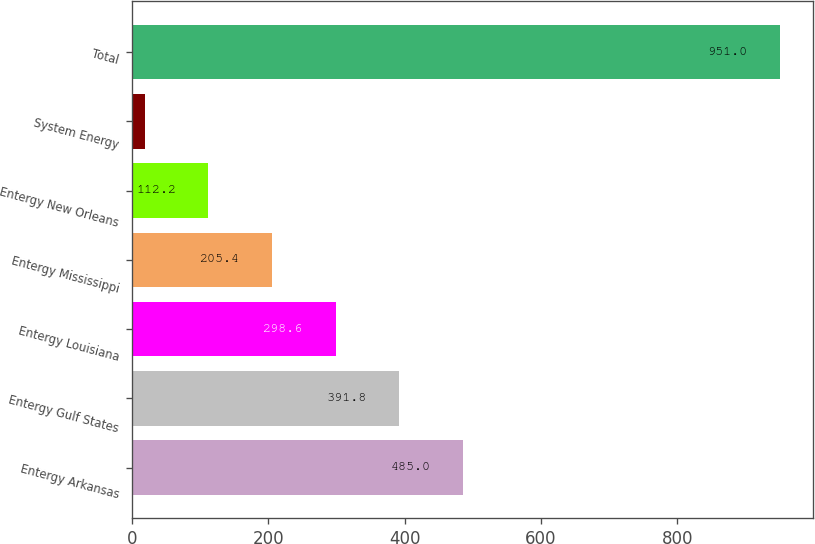Convert chart to OTSL. <chart><loc_0><loc_0><loc_500><loc_500><bar_chart><fcel>Entergy Arkansas<fcel>Entergy Gulf States<fcel>Entergy Louisiana<fcel>Entergy Mississippi<fcel>Entergy New Orleans<fcel>System Energy<fcel>Total<nl><fcel>485<fcel>391.8<fcel>298.6<fcel>205.4<fcel>112.2<fcel>19<fcel>951<nl></chart> 